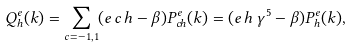<formula> <loc_0><loc_0><loc_500><loc_500>Q _ { h } ^ { e } ( k ) = \sum _ { c = - 1 , 1 } ( e \, c \, h - \beta ) P _ { c h } ^ { e } ( k ) = ( e \, h \, \gamma ^ { 5 } - \beta ) P _ { h } ^ { e } ( k ) ,</formula> 